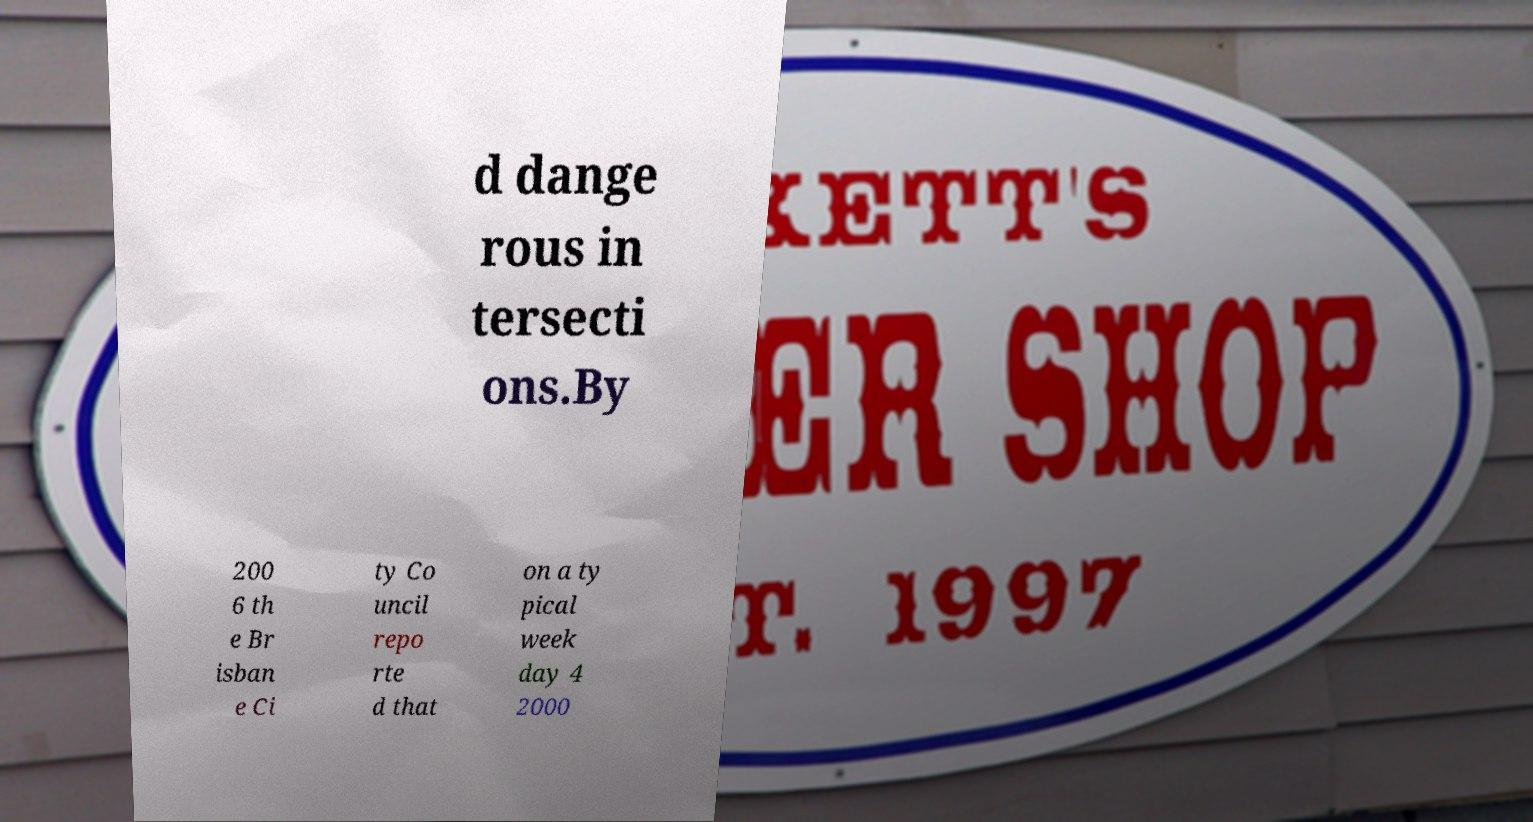For documentation purposes, I need the text within this image transcribed. Could you provide that? d dange rous in tersecti ons.By 200 6 th e Br isban e Ci ty Co uncil repo rte d that on a ty pical week day 4 2000 